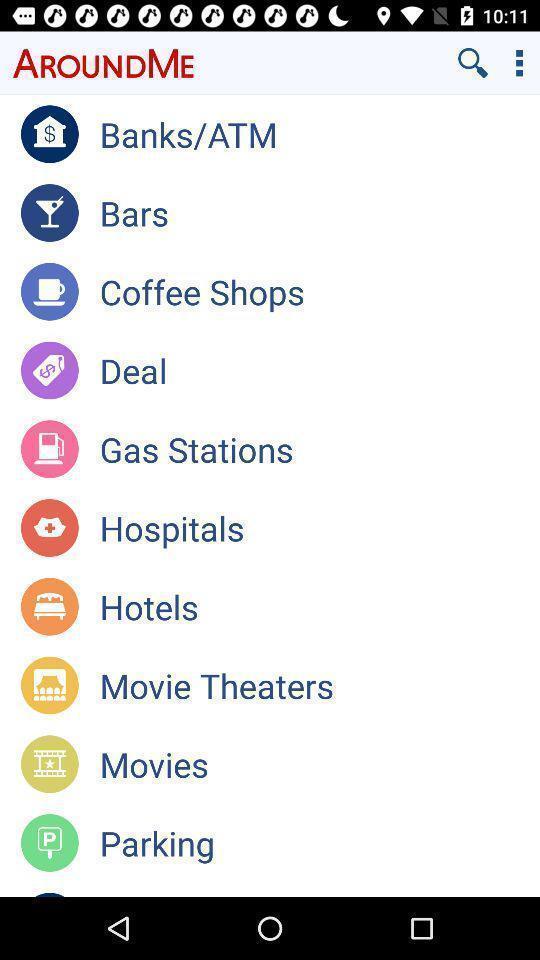What can you discern from this picture? Page shows different places near. 